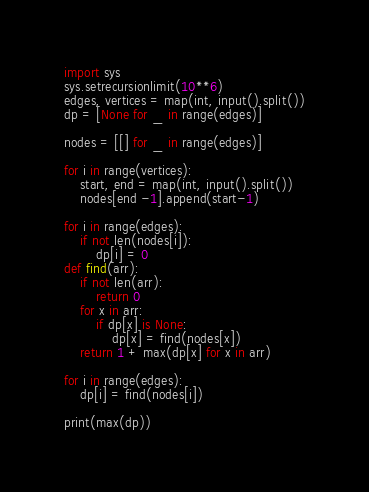<code> <loc_0><loc_0><loc_500><loc_500><_Python_>import sys
sys.setrecursionlimit(10**6)
edges, vertices = map(int, input().split())
dp = [None for _ in range(edges)]

nodes = [[] for _ in range(edges)]

for i in range(vertices):
    start, end = map(int, input().split())
    nodes[end -1].append(start-1)

for i in range(edges):
    if not len(nodes[i]):
        dp[i] = 0
def find(arr):
    if not len(arr):
        return 0
    for x in arr:
        if dp[x] is None:
            dp[x] = find(nodes[x])
    return 1 + max(dp[x] for x in arr)

for i in range(edges):
    dp[i] = find(nodes[i])

print(max(dp))
</code> 